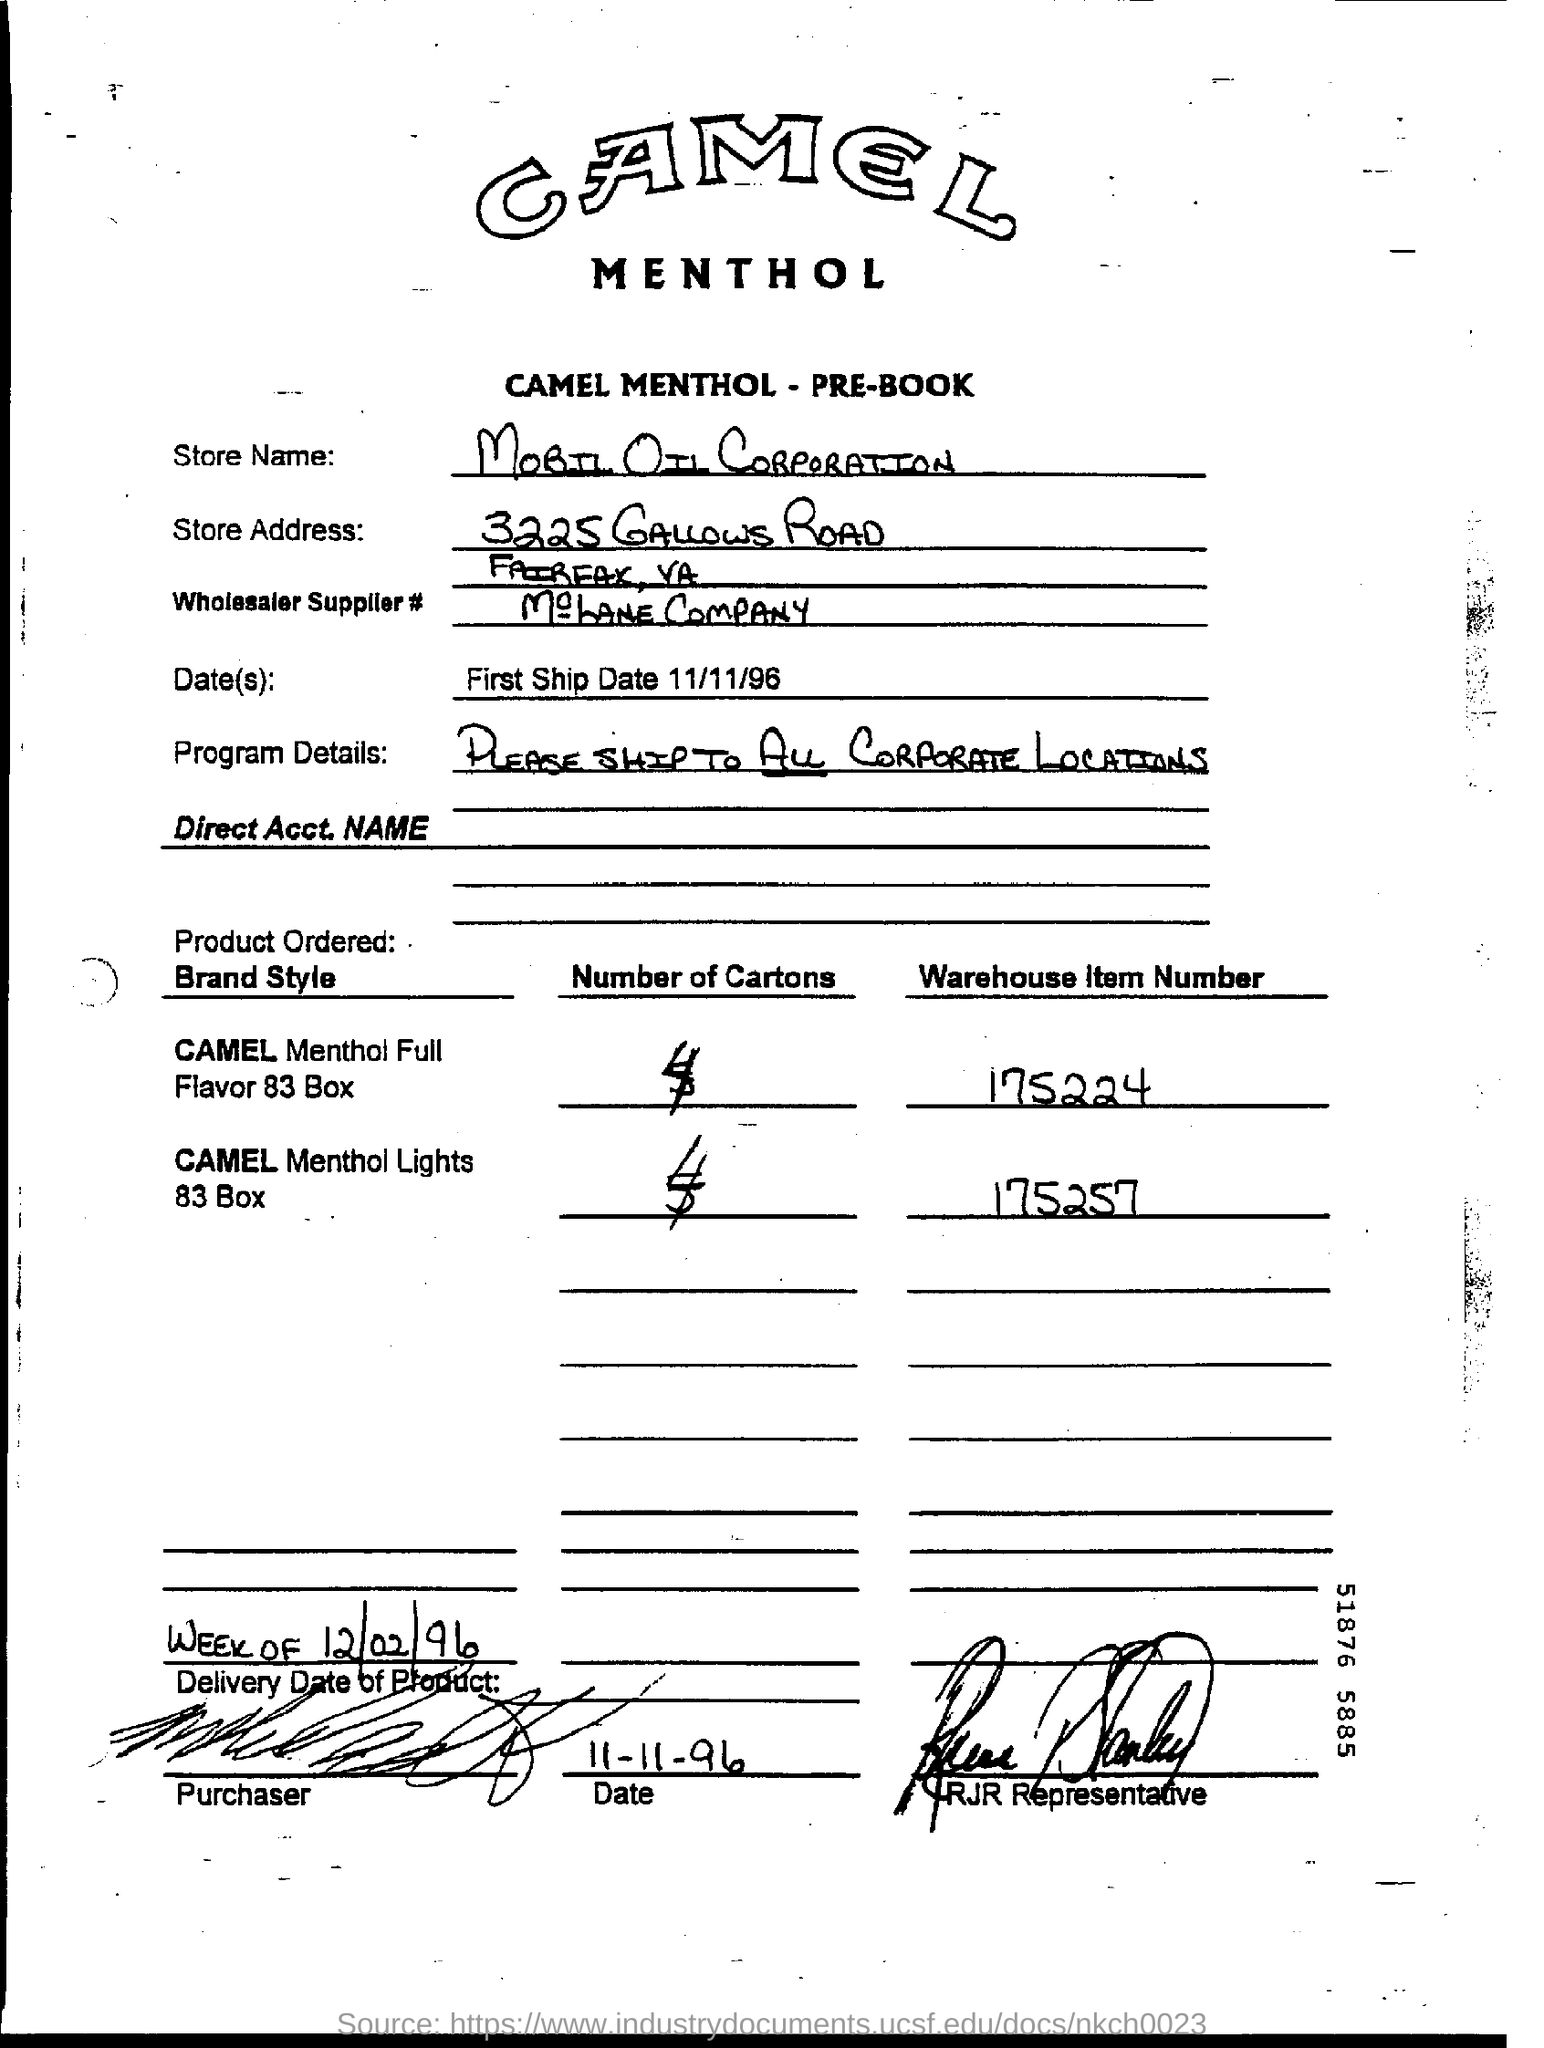What is the store name in the given document?
Your answer should be very brief. Mobil oil corporation. What is "First ship date"?
Give a very brief answer. 11/11/96. 